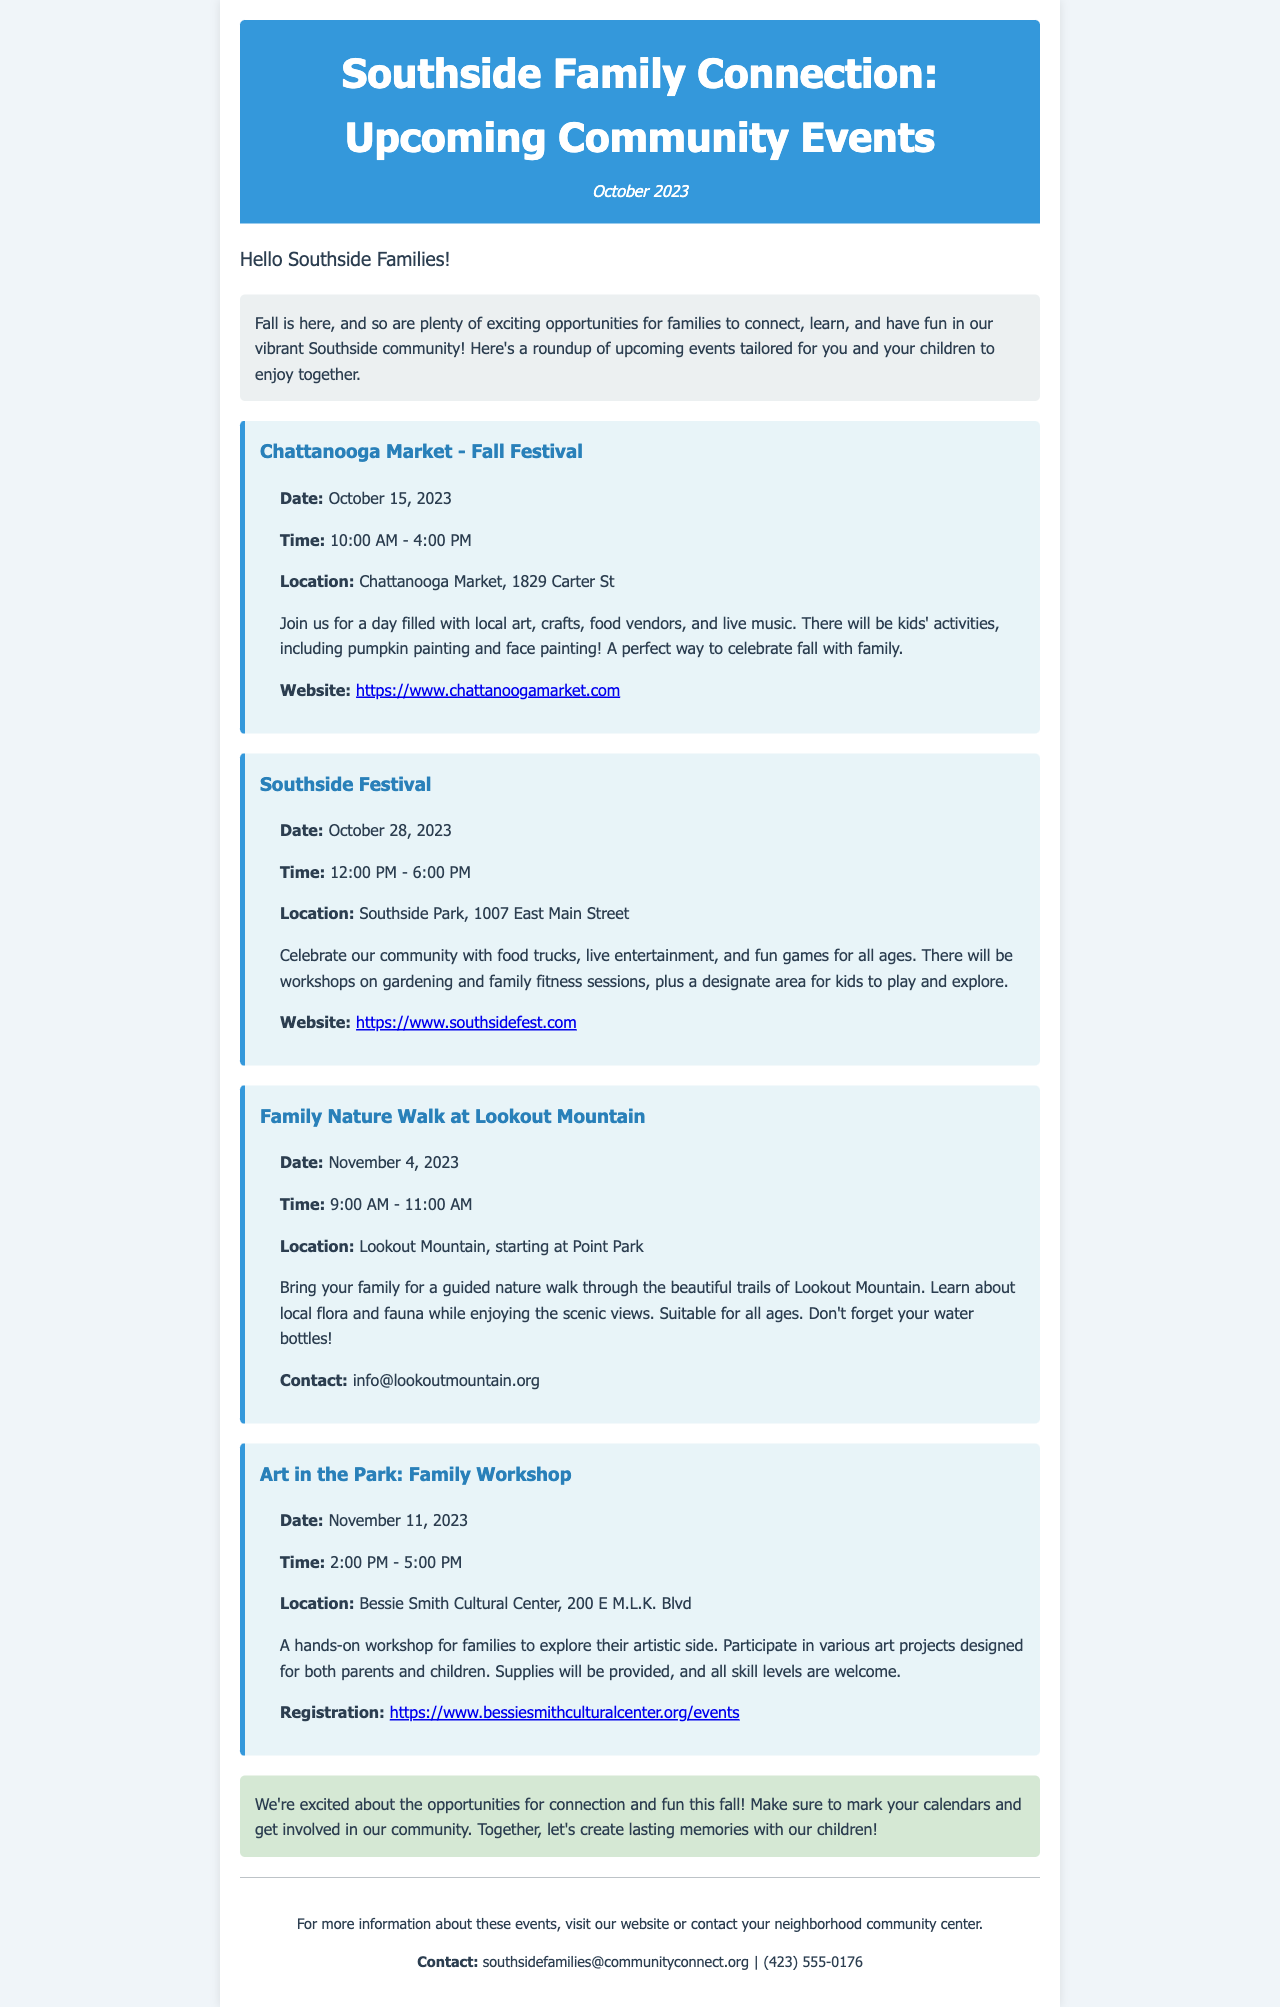what is the date of the Chattanooga Market - Fall Festival? The document states that the Chattanooga Market - Fall Festival is scheduled for October 15, 2023.
Answer: October 15, 2023 what activities are available for kids at the Chattanooga Market - Fall Festival? The document mentions kids' activities such as pumpkin painting and face painting.
Answer: Pumpkin painting and face painting what time does the Southside Festival begin? According to the document, the Southside Festival starts at 12:00 PM.
Answer: 12:00 PM where is the Family Nature Walk at Lookout Mountain taking place? The event is located at Lookout Mountain, starting at Point Park as stated in the document.
Answer: Lookout Mountain, starting at Point Park what type of event is the Art in the Park described as? The document describes the Art in the Park event as a hands-on workshop for families.
Answer: Hands-on workshop how long is the Family Nature Walk scheduled to last? The document indicates that the Family Nature Walk is from 9:00 AM to 11:00 AM, which is a duration of 2 hours.
Answer: 2 hours what is the contact email for the Family Nature Walk at Lookout Mountain? The contact email provided in the document for the Family Nature Walk is info@lookoutmountain.org.
Answer: info@lookoutmountain.org what types of food options will be available at the Southside Festival? The document states that there will be food trucks available at the Southside Festival.
Answer: Food trucks how can families register for the Art in the Park workshop? It is stated in the document that registration can be done through the provided website link.
Answer: Through the provided website link 